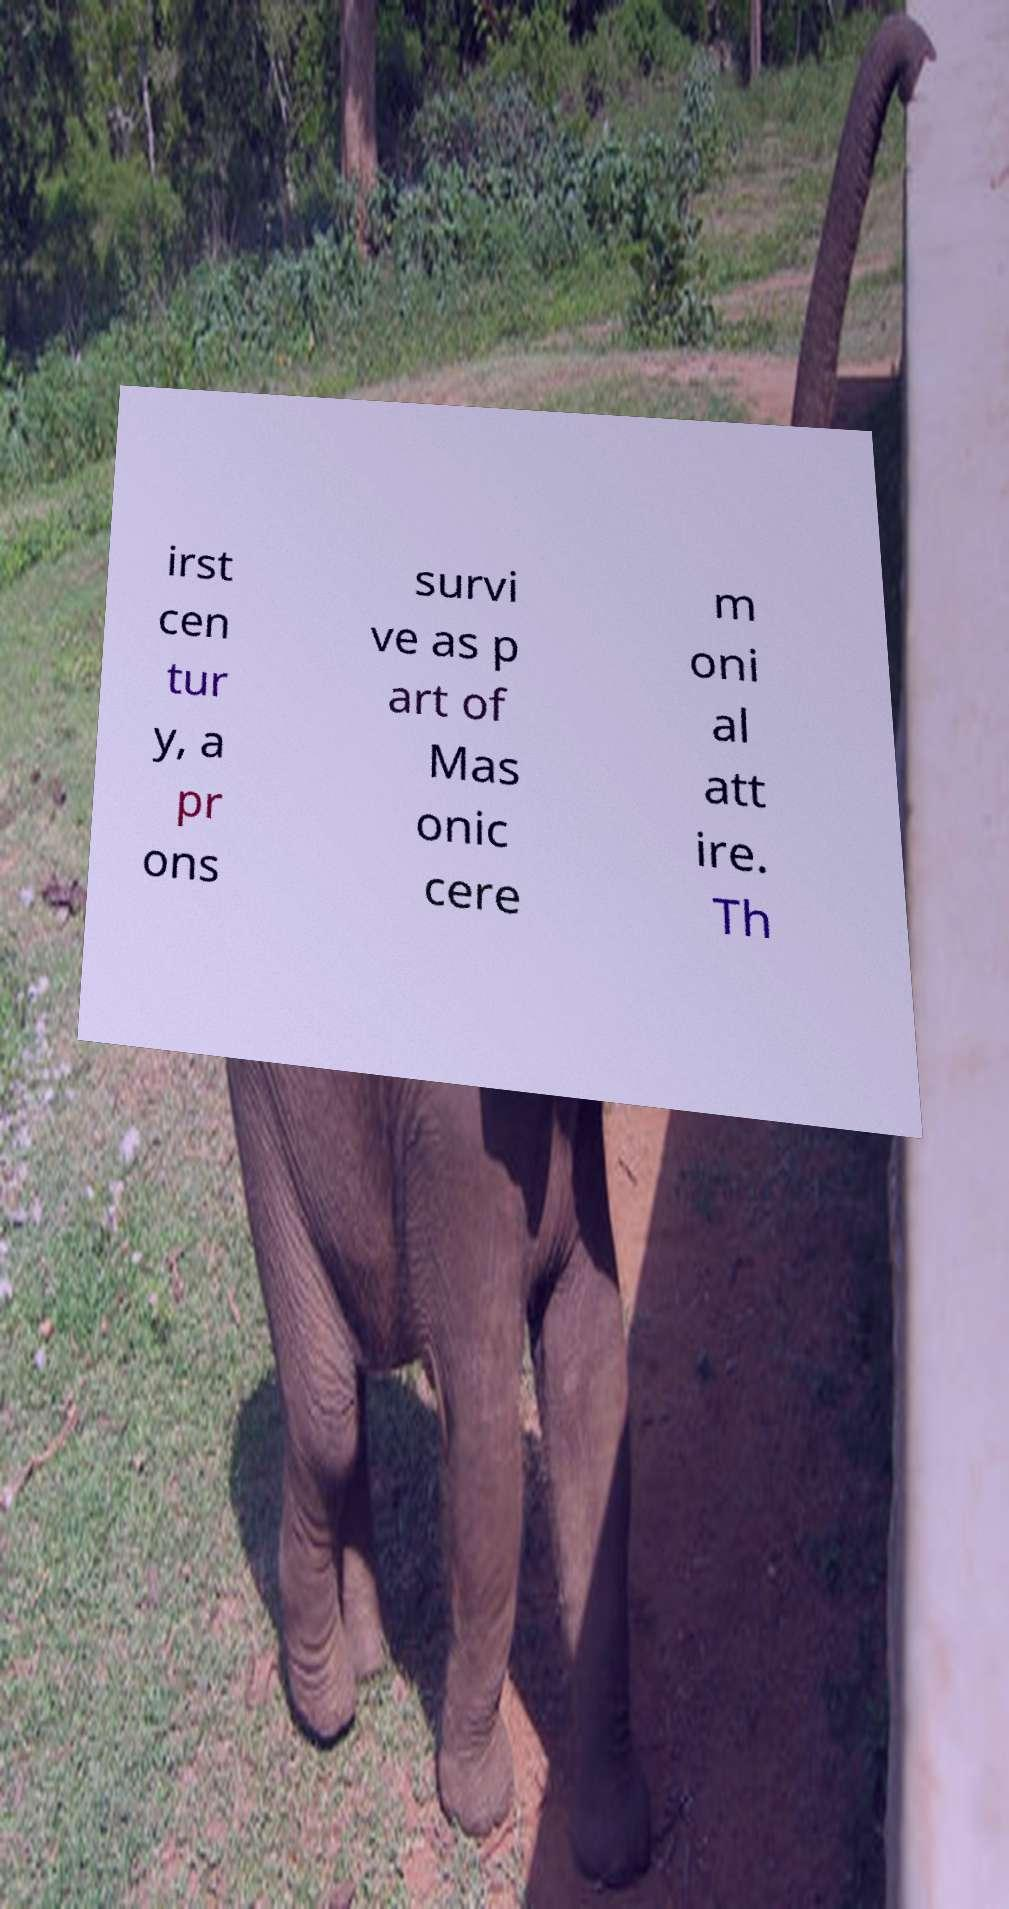Can you read and provide the text displayed in the image?This photo seems to have some interesting text. Can you extract and type it out for me? irst cen tur y, a pr ons survi ve as p art of Mas onic cere m oni al att ire. Th 